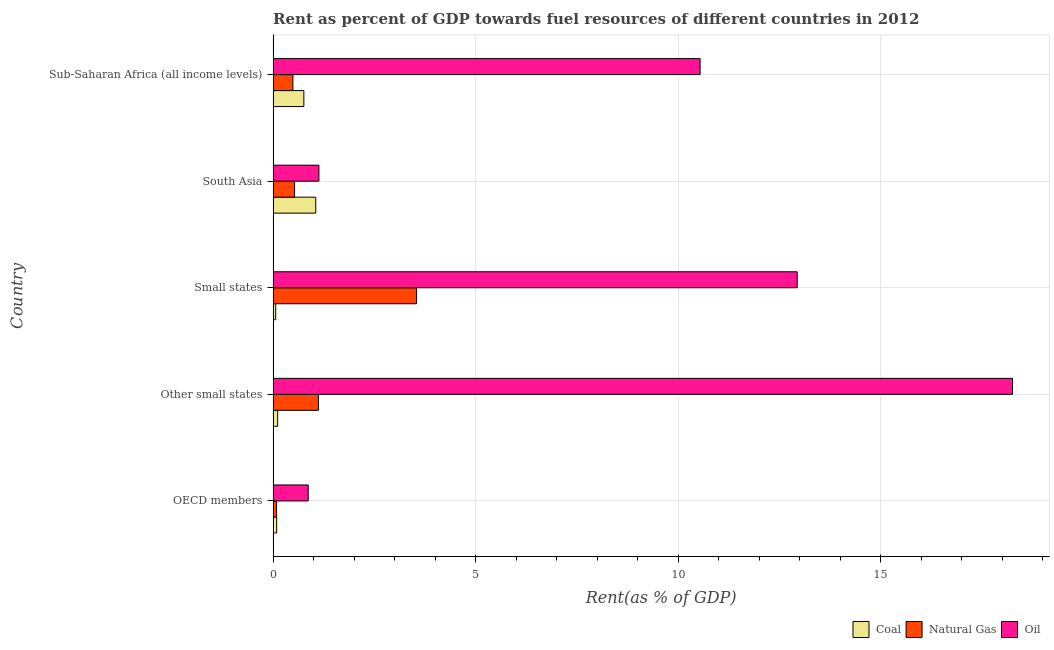How many groups of bars are there?
Your answer should be very brief. 5. Are the number of bars on each tick of the Y-axis equal?
Give a very brief answer. Yes. How many bars are there on the 2nd tick from the bottom?
Give a very brief answer. 3. What is the label of the 3rd group of bars from the top?
Offer a terse response. Small states. In how many cases, is the number of bars for a given country not equal to the number of legend labels?
Offer a very short reply. 0. What is the rent towards coal in Other small states?
Keep it short and to the point. 0.11. Across all countries, what is the maximum rent towards oil?
Provide a short and direct response. 18.25. Across all countries, what is the minimum rent towards coal?
Offer a terse response. 0.06. In which country was the rent towards coal maximum?
Offer a terse response. South Asia. In which country was the rent towards oil minimum?
Offer a very short reply. OECD members. What is the total rent towards oil in the graph?
Your response must be concise. 43.72. What is the difference between the rent towards natural gas in Other small states and that in Sub-Saharan Africa (all income levels)?
Give a very brief answer. 0.63. What is the difference between the rent towards natural gas in South Asia and the rent towards oil in Small states?
Make the answer very short. -12.4. What is the average rent towards coal per country?
Offer a very short reply. 0.41. What is the difference between the rent towards coal and rent towards natural gas in Other small states?
Your response must be concise. -1.01. What is the ratio of the rent towards oil in Other small states to that in Sub-Saharan Africa (all income levels)?
Your answer should be very brief. 1.73. Is the difference between the rent towards oil in Other small states and South Asia greater than the difference between the rent towards natural gas in Other small states and South Asia?
Provide a succinct answer. Yes. What is the difference between the highest and the second highest rent towards coal?
Your answer should be compact. 0.29. What is the difference between the highest and the lowest rent towards coal?
Your response must be concise. 0.99. Is the sum of the rent towards natural gas in Other small states and Small states greater than the maximum rent towards oil across all countries?
Your response must be concise. No. What does the 2nd bar from the top in Other small states represents?
Give a very brief answer. Natural Gas. What does the 3rd bar from the bottom in OECD members represents?
Your response must be concise. Oil. Is it the case that in every country, the sum of the rent towards coal and rent towards natural gas is greater than the rent towards oil?
Offer a very short reply. No. How many bars are there?
Offer a terse response. 15. How many countries are there in the graph?
Offer a very short reply. 5. What is the difference between two consecutive major ticks on the X-axis?
Ensure brevity in your answer.  5. Does the graph contain any zero values?
Your response must be concise. No. Where does the legend appear in the graph?
Your answer should be very brief. Bottom right. What is the title of the graph?
Offer a terse response. Rent as percent of GDP towards fuel resources of different countries in 2012. What is the label or title of the X-axis?
Provide a succinct answer. Rent(as % of GDP). What is the Rent(as % of GDP) in Coal in OECD members?
Make the answer very short. 0.09. What is the Rent(as % of GDP) of Natural Gas in OECD members?
Offer a terse response. 0.09. What is the Rent(as % of GDP) of Oil in OECD members?
Provide a short and direct response. 0.87. What is the Rent(as % of GDP) in Coal in Other small states?
Provide a succinct answer. 0.11. What is the Rent(as % of GDP) of Natural Gas in Other small states?
Provide a succinct answer. 1.12. What is the Rent(as % of GDP) in Oil in Other small states?
Your answer should be very brief. 18.25. What is the Rent(as % of GDP) of Coal in Small states?
Your answer should be very brief. 0.06. What is the Rent(as % of GDP) in Natural Gas in Small states?
Your answer should be very brief. 3.54. What is the Rent(as % of GDP) of Oil in Small states?
Your answer should be very brief. 12.93. What is the Rent(as % of GDP) in Coal in South Asia?
Provide a succinct answer. 1.05. What is the Rent(as % of GDP) of Natural Gas in South Asia?
Keep it short and to the point. 0.53. What is the Rent(as % of GDP) of Oil in South Asia?
Make the answer very short. 1.13. What is the Rent(as % of GDP) of Coal in Sub-Saharan Africa (all income levels)?
Offer a very short reply. 0.76. What is the Rent(as % of GDP) in Natural Gas in Sub-Saharan Africa (all income levels)?
Your answer should be very brief. 0.49. What is the Rent(as % of GDP) in Oil in Sub-Saharan Africa (all income levels)?
Your answer should be compact. 10.54. Across all countries, what is the maximum Rent(as % of GDP) in Coal?
Give a very brief answer. 1.05. Across all countries, what is the maximum Rent(as % of GDP) of Natural Gas?
Provide a succinct answer. 3.54. Across all countries, what is the maximum Rent(as % of GDP) in Oil?
Offer a terse response. 18.25. Across all countries, what is the minimum Rent(as % of GDP) in Coal?
Your response must be concise. 0.06. Across all countries, what is the minimum Rent(as % of GDP) in Natural Gas?
Your response must be concise. 0.09. Across all countries, what is the minimum Rent(as % of GDP) in Oil?
Your response must be concise. 0.87. What is the total Rent(as % of GDP) in Coal in the graph?
Keep it short and to the point. 2.07. What is the total Rent(as % of GDP) of Natural Gas in the graph?
Offer a very short reply. 5.76. What is the total Rent(as % of GDP) of Oil in the graph?
Offer a very short reply. 43.72. What is the difference between the Rent(as % of GDP) of Coal in OECD members and that in Other small states?
Offer a terse response. -0.02. What is the difference between the Rent(as % of GDP) of Natural Gas in OECD members and that in Other small states?
Your answer should be compact. -1.03. What is the difference between the Rent(as % of GDP) of Oil in OECD members and that in Other small states?
Your answer should be compact. -17.38. What is the difference between the Rent(as % of GDP) of Coal in OECD members and that in Small states?
Provide a short and direct response. 0.02. What is the difference between the Rent(as % of GDP) in Natural Gas in OECD members and that in Small states?
Offer a very short reply. -3.45. What is the difference between the Rent(as % of GDP) in Oil in OECD members and that in Small states?
Ensure brevity in your answer.  -12.07. What is the difference between the Rent(as % of GDP) of Coal in OECD members and that in South Asia?
Provide a short and direct response. -0.96. What is the difference between the Rent(as % of GDP) of Natural Gas in OECD members and that in South Asia?
Provide a succinct answer. -0.44. What is the difference between the Rent(as % of GDP) of Oil in OECD members and that in South Asia?
Your response must be concise. -0.26. What is the difference between the Rent(as % of GDP) in Coal in OECD members and that in Sub-Saharan Africa (all income levels)?
Your response must be concise. -0.67. What is the difference between the Rent(as % of GDP) of Natural Gas in OECD members and that in Sub-Saharan Africa (all income levels)?
Ensure brevity in your answer.  -0.4. What is the difference between the Rent(as % of GDP) in Oil in OECD members and that in Sub-Saharan Africa (all income levels)?
Your answer should be compact. -9.67. What is the difference between the Rent(as % of GDP) of Coal in Other small states and that in Small states?
Your response must be concise. 0.05. What is the difference between the Rent(as % of GDP) of Natural Gas in Other small states and that in Small states?
Offer a terse response. -2.42. What is the difference between the Rent(as % of GDP) in Oil in Other small states and that in Small states?
Provide a short and direct response. 5.31. What is the difference between the Rent(as % of GDP) of Coal in Other small states and that in South Asia?
Ensure brevity in your answer.  -0.94. What is the difference between the Rent(as % of GDP) in Natural Gas in Other small states and that in South Asia?
Give a very brief answer. 0.59. What is the difference between the Rent(as % of GDP) in Oil in Other small states and that in South Asia?
Your answer should be very brief. 17.12. What is the difference between the Rent(as % of GDP) in Coal in Other small states and that in Sub-Saharan Africa (all income levels)?
Provide a short and direct response. -0.65. What is the difference between the Rent(as % of GDP) of Natural Gas in Other small states and that in Sub-Saharan Africa (all income levels)?
Make the answer very short. 0.63. What is the difference between the Rent(as % of GDP) in Oil in Other small states and that in Sub-Saharan Africa (all income levels)?
Offer a very short reply. 7.71. What is the difference between the Rent(as % of GDP) of Coal in Small states and that in South Asia?
Offer a very short reply. -0.99. What is the difference between the Rent(as % of GDP) in Natural Gas in Small states and that in South Asia?
Make the answer very short. 3.01. What is the difference between the Rent(as % of GDP) of Oil in Small states and that in South Asia?
Your answer should be compact. 11.8. What is the difference between the Rent(as % of GDP) of Coal in Small states and that in Sub-Saharan Africa (all income levels)?
Make the answer very short. -0.7. What is the difference between the Rent(as % of GDP) of Natural Gas in Small states and that in Sub-Saharan Africa (all income levels)?
Offer a very short reply. 3.05. What is the difference between the Rent(as % of GDP) in Oil in Small states and that in Sub-Saharan Africa (all income levels)?
Offer a terse response. 2.4. What is the difference between the Rent(as % of GDP) of Coal in South Asia and that in Sub-Saharan Africa (all income levels)?
Offer a very short reply. 0.29. What is the difference between the Rent(as % of GDP) in Natural Gas in South Asia and that in Sub-Saharan Africa (all income levels)?
Give a very brief answer. 0.04. What is the difference between the Rent(as % of GDP) of Oil in South Asia and that in Sub-Saharan Africa (all income levels)?
Give a very brief answer. -9.41. What is the difference between the Rent(as % of GDP) of Coal in OECD members and the Rent(as % of GDP) of Natural Gas in Other small states?
Offer a terse response. -1.03. What is the difference between the Rent(as % of GDP) of Coal in OECD members and the Rent(as % of GDP) of Oil in Other small states?
Ensure brevity in your answer.  -18.16. What is the difference between the Rent(as % of GDP) of Natural Gas in OECD members and the Rent(as % of GDP) of Oil in Other small states?
Your answer should be compact. -18.16. What is the difference between the Rent(as % of GDP) in Coal in OECD members and the Rent(as % of GDP) in Natural Gas in Small states?
Your response must be concise. -3.45. What is the difference between the Rent(as % of GDP) of Coal in OECD members and the Rent(as % of GDP) of Oil in Small states?
Provide a succinct answer. -12.85. What is the difference between the Rent(as % of GDP) in Natural Gas in OECD members and the Rent(as % of GDP) in Oil in Small states?
Provide a succinct answer. -12.85. What is the difference between the Rent(as % of GDP) in Coal in OECD members and the Rent(as % of GDP) in Natural Gas in South Asia?
Offer a terse response. -0.44. What is the difference between the Rent(as % of GDP) of Coal in OECD members and the Rent(as % of GDP) of Oil in South Asia?
Your answer should be very brief. -1.04. What is the difference between the Rent(as % of GDP) of Natural Gas in OECD members and the Rent(as % of GDP) of Oil in South Asia?
Your answer should be compact. -1.04. What is the difference between the Rent(as % of GDP) in Coal in OECD members and the Rent(as % of GDP) in Natural Gas in Sub-Saharan Africa (all income levels)?
Make the answer very short. -0.4. What is the difference between the Rent(as % of GDP) in Coal in OECD members and the Rent(as % of GDP) in Oil in Sub-Saharan Africa (all income levels)?
Offer a terse response. -10.45. What is the difference between the Rent(as % of GDP) of Natural Gas in OECD members and the Rent(as % of GDP) of Oil in Sub-Saharan Africa (all income levels)?
Provide a succinct answer. -10.45. What is the difference between the Rent(as % of GDP) of Coal in Other small states and the Rent(as % of GDP) of Natural Gas in Small states?
Your response must be concise. -3.43. What is the difference between the Rent(as % of GDP) in Coal in Other small states and the Rent(as % of GDP) in Oil in Small states?
Keep it short and to the point. -12.82. What is the difference between the Rent(as % of GDP) of Natural Gas in Other small states and the Rent(as % of GDP) of Oil in Small states?
Provide a succinct answer. -11.82. What is the difference between the Rent(as % of GDP) of Coal in Other small states and the Rent(as % of GDP) of Natural Gas in South Asia?
Give a very brief answer. -0.42. What is the difference between the Rent(as % of GDP) of Coal in Other small states and the Rent(as % of GDP) of Oil in South Asia?
Your answer should be very brief. -1.02. What is the difference between the Rent(as % of GDP) in Natural Gas in Other small states and the Rent(as % of GDP) in Oil in South Asia?
Your response must be concise. -0.01. What is the difference between the Rent(as % of GDP) in Coal in Other small states and the Rent(as % of GDP) in Natural Gas in Sub-Saharan Africa (all income levels)?
Your response must be concise. -0.38. What is the difference between the Rent(as % of GDP) in Coal in Other small states and the Rent(as % of GDP) in Oil in Sub-Saharan Africa (all income levels)?
Your answer should be very brief. -10.43. What is the difference between the Rent(as % of GDP) in Natural Gas in Other small states and the Rent(as % of GDP) in Oil in Sub-Saharan Africa (all income levels)?
Make the answer very short. -9.42. What is the difference between the Rent(as % of GDP) in Coal in Small states and the Rent(as % of GDP) in Natural Gas in South Asia?
Offer a terse response. -0.47. What is the difference between the Rent(as % of GDP) of Coal in Small states and the Rent(as % of GDP) of Oil in South Asia?
Keep it short and to the point. -1.07. What is the difference between the Rent(as % of GDP) of Natural Gas in Small states and the Rent(as % of GDP) of Oil in South Asia?
Your answer should be compact. 2.41. What is the difference between the Rent(as % of GDP) in Coal in Small states and the Rent(as % of GDP) in Natural Gas in Sub-Saharan Africa (all income levels)?
Offer a very short reply. -0.42. What is the difference between the Rent(as % of GDP) of Coal in Small states and the Rent(as % of GDP) of Oil in Sub-Saharan Africa (all income levels)?
Provide a short and direct response. -10.47. What is the difference between the Rent(as % of GDP) of Natural Gas in Small states and the Rent(as % of GDP) of Oil in Sub-Saharan Africa (all income levels)?
Your answer should be compact. -7. What is the difference between the Rent(as % of GDP) in Coal in South Asia and the Rent(as % of GDP) in Natural Gas in Sub-Saharan Africa (all income levels)?
Give a very brief answer. 0.56. What is the difference between the Rent(as % of GDP) in Coal in South Asia and the Rent(as % of GDP) in Oil in Sub-Saharan Africa (all income levels)?
Provide a short and direct response. -9.49. What is the difference between the Rent(as % of GDP) of Natural Gas in South Asia and the Rent(as % of GDP) of Oil in Sub-Saharan Africa (all income levels)?
Offer a very short reply. -10.01. What is the average Rent(as % of GDP) of Coal per country?
Keep it short and to the point. 0.41. What is the average Rent(as % of GDP) in Natural Gas per country?
Your answer should be compact. 1.15. What is the average Rent(as % of GDP) of Oil per country?
Keep it short and to the point. 8.74. What is the difference between the Rent(as % of GDP) in Coal and Rent(as % of GDP) in Natural Gas in OECD members?
Make the answer very short. 0. What is the difference between the Rent(as % of GDP) in Coal and Rent(as % of GDP) in Oil in OECD members?
Offer a very short reply. -0.78. What is the difference between the Rent(as % of GDP) in Natural Gas and Rent(as % of GDP) in Oil in OECD members?
Offer a terse response. -0.78. What is the difference between the Rent(as % of GDP) of Coal and Rent(as % of GDP) of Natural Gas in Other small states?
Make the answer very short. -1.01. What is the difference between the Rent(as % of GDP) of Coal and Rent(as % of GDP) of Oil in Other small states?
Give a very brief answer. -18.14. What is the difference between the Rent(as % of GDP) of Natural Gas and Rent(as % of GDP) of Oil in Other small states?
Offer a very short reply. -17.13. What is the difference between the Rent(as % of GDP) in Coal and Rent(as % of GDP) in Natural Gas in Small states?
Make the answer very short. -3.48. What is the difference between the Rent(as % of GDP) in Coal and Rent(as % of GDP) in Oil in Small states?
Give a very brief answer. -12.87. What is the difference between the Rent(as % of GDP) in Natural Gas and Rent(as % of GDP) in Oil in Small states?
Offer a terse response. -9.39. What is the difference between the Rent(as % of GDP) in Coal and Rent(as % of GDP) in Natural Gas in South Asia?
Provide a succinct answer. 0.52. What is the difference between the Rent(as % of GDP) in Coal and Rent(as % of GDP) in Oil in South Asia?
Provide a succinct answer. -0.08. What is the difference between the Rent(as % of GDP) of Natural Gas and Rent(as % of GDP) of Oil in South Asia?
Make the answer very short. -0.6. What is the difference between the Rent(as % of GDP) in Coal and Rent(as % of GDP) in Natural Gas in Sub-Saharan Africa (all income levels)?
Your answer should be very brief. 0.27. What is the difference between the Rent(as % of GDP) of Coal and Rent(as % of GDP) of Oil in Sub-Saharan Africa (all income levels)?
Your response must be concise. -9.78. What is the difference between the Rent(as % of GDP) of Natural Gas and Rent(as % of GDP) of Oil in Sub-Saharan Africa (all income levels)?
Ensure brevity in your answer.  -10.05. What is the ratio of the Rent(as % of GDP) of Coal in OECD members to that in Other small states?
Your response must be concise. 0.79. What is the ratio of the Rent(as % of GDP) in Natural Gas in OECD members to that in Other small states?
Your response must be concise. 0.08. What is the ratio of the Rent(as % of GDP) in Oil in OECD members to that in Other small states?
Provide a short and direct response. 0.05. What is the ratio of the Rent(as % of GDP) of Coal in OECD members to that in Small states?
Provide a succinct answer. 1.39. What is the ratio of the Rent(as % of GDP) of Natural Gas in OECD members to that in Small states?
Make the answer very short. 0.02. What is the ratio of the Rent(as % of GDP) of Oil in OECD members to that in Small states?
Make the answer very short. 0.07. What is the ratio of the Rent(as % of GDP) in Coal in OECD members to that in South Asia?
Your answer should be very brief. 0.08. What is the ratio of the Rent(as % of GDP) of Natural Gas in OECD members to that in South Asia?
Your answer should be compact. 0.16. What is the ratio of the Rent(as % of GDP) in Oil in OECD members to that in South Asia?
Your response must be concise. 0.77. What is the ratio of the Rent(as % of GDP) in Coal in OECD members to that in Sub-Saharan Africa (all income levels)?
Give a very brief answer. 0.12. What is the ratio of the Rent(as % of GDP) in Natural Gas in OECD members to that in Sub-Saharan Africa (all income levels)?
Offer a terse response. 0.17. What is the ratio of the Rent(as % of GDP) of Oil in OECD members to that in Sub-Saharan Africa (all income levels)?
Give a very brief answer. 0.08. What is the ratio of the Rent(as % of GDP) of Coal in Other small states to that in Small states?
Offer a very short reply. 1.77. What is the ratio of the Rent(as % of GDP) of Natural Gas in Other small states to that in Small states?
Keep it short and to the point. 0.32. What is the ratio of the Rent(as % of GDP) in Oil in Other small states to that in Small states?
Make the answer very short. 1.41. What is the ratio of the Rent(as % of GDP) in Coal in Other small states to that in South Asia?
Make the answer very short. 0.11. What is the ratio of the Rent(as % of GDP) in Natural Gas in Other small states to that in South Asia?
Make the answer very short. 2.11. What is the ratio of the Rent(as % of GDP) of Oil in Other small states to that in South Asia?
Offer a very short reply. 16.15. What is the ratio of the Rent(as % of GDP) in Coal in Other small states to that in Sub-Saharan Africa (all income levels)?
Provide a succinct answer. 0.15. What is the ratio of the Rent(as % of GDP) of Natural Gas in Other small states to that in Sub-Saharan Africa (all income levels)?
Provide a short and direct response. 2.29. What is the ratio of the Rent(as % of GDP) in Oil in Other small states to that in Sub-Saharan Africa (all income levels)?
Give a very brief answer. 1.73. What is the ratio of the Rent(as % of GDP) in Coal in Small states to that in South Asia?
Ensure brevity in your answer.  0.06. What is the ratio of the Rent(as % of GDP) in Natural Gas in Small states to that in South Asia?
Your answer should be compact. 6.68. What is the ratio of the Rent(as % of GDP) of Oil in Small states to that in South Asia?
Provide a succinct answer. 11.45. What is the ratio of the Rent(as % of GDP) in Coal in Small states to that in Sub-Saharan Africa (all income levels)?
Your response must be concise. 0.08. What is the ratio of the Rent(as % of GDP) of Natural Gas in Small states to that in Sub-Saharan Africa (all income levels)?
Ensure brevity in your answer.  7.25. What is the ratio of the Rent(as % of GDP) of Oil in Small states to that in Sub-Saharan Africa (all income levels)?
Offer a very short reply. 1.23. What is the ratio of the Rent(as % of GDP) in Coal in South Asia to that in Sub-Saharan Africa (all income levels)?
Offer a very short reply. 1.39. What is the ratio of the Rent(as % of GDP) of Natural Gas in South Asia to that in Sub-Saharan Africa (all income levels)?
Give a very brief answer. 1.09. What is the ratio of the Rent(as % of GDP) in Oil in South Asia to that in Sub-Saharan Africa (all income levels)?
Provide a short and direct response. 0.11. What is the difference between the highest and the second highest Rent(as % of GDP) in Coal?
Provide a short and direct response. 0.29. What is the difference between the highest and the second highest Rent(as % of GDP) of Natural Gas?
Your answer should be very brief. 2.42. What is the difference between the highest and the second highest Rent(as % of GDP) of Oil?
Provide a short and direct response. 5.31. What is the difference between the highest and the lowest Rent(as % of GDP) of Coal?
Offer a very short reply. 0.99. What is the difference between the highest and the lowest Rent(as % of GDP) of Natural Gas?
Your response must be concise. 3.45. What is the difference between the highest and the lowest Rent(as % of GDP) of Oil?
Your answer should be compact. 17.38. 